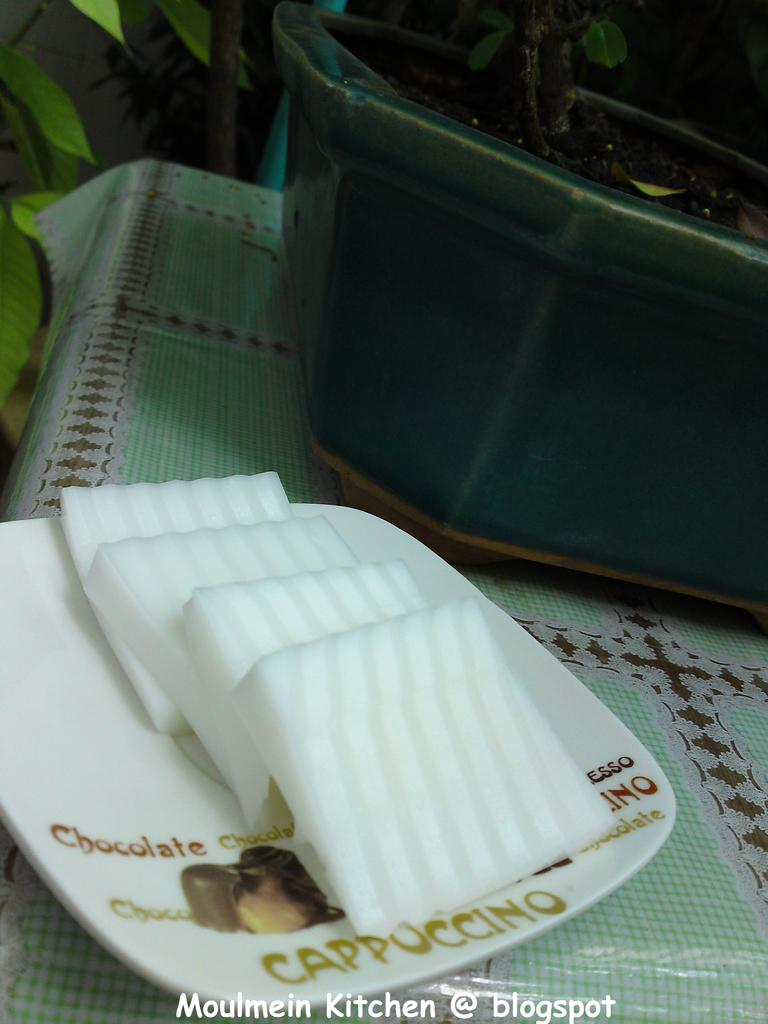What is on the table in the image? There is a plant and a plate on the table. What else can be seen on the table besides the plant and plate? There is food on the table. What system is responsible for causing the food to appear on the table? There is no system responsible for causing the food to appear on the table in the image. The food is simply placed there. 